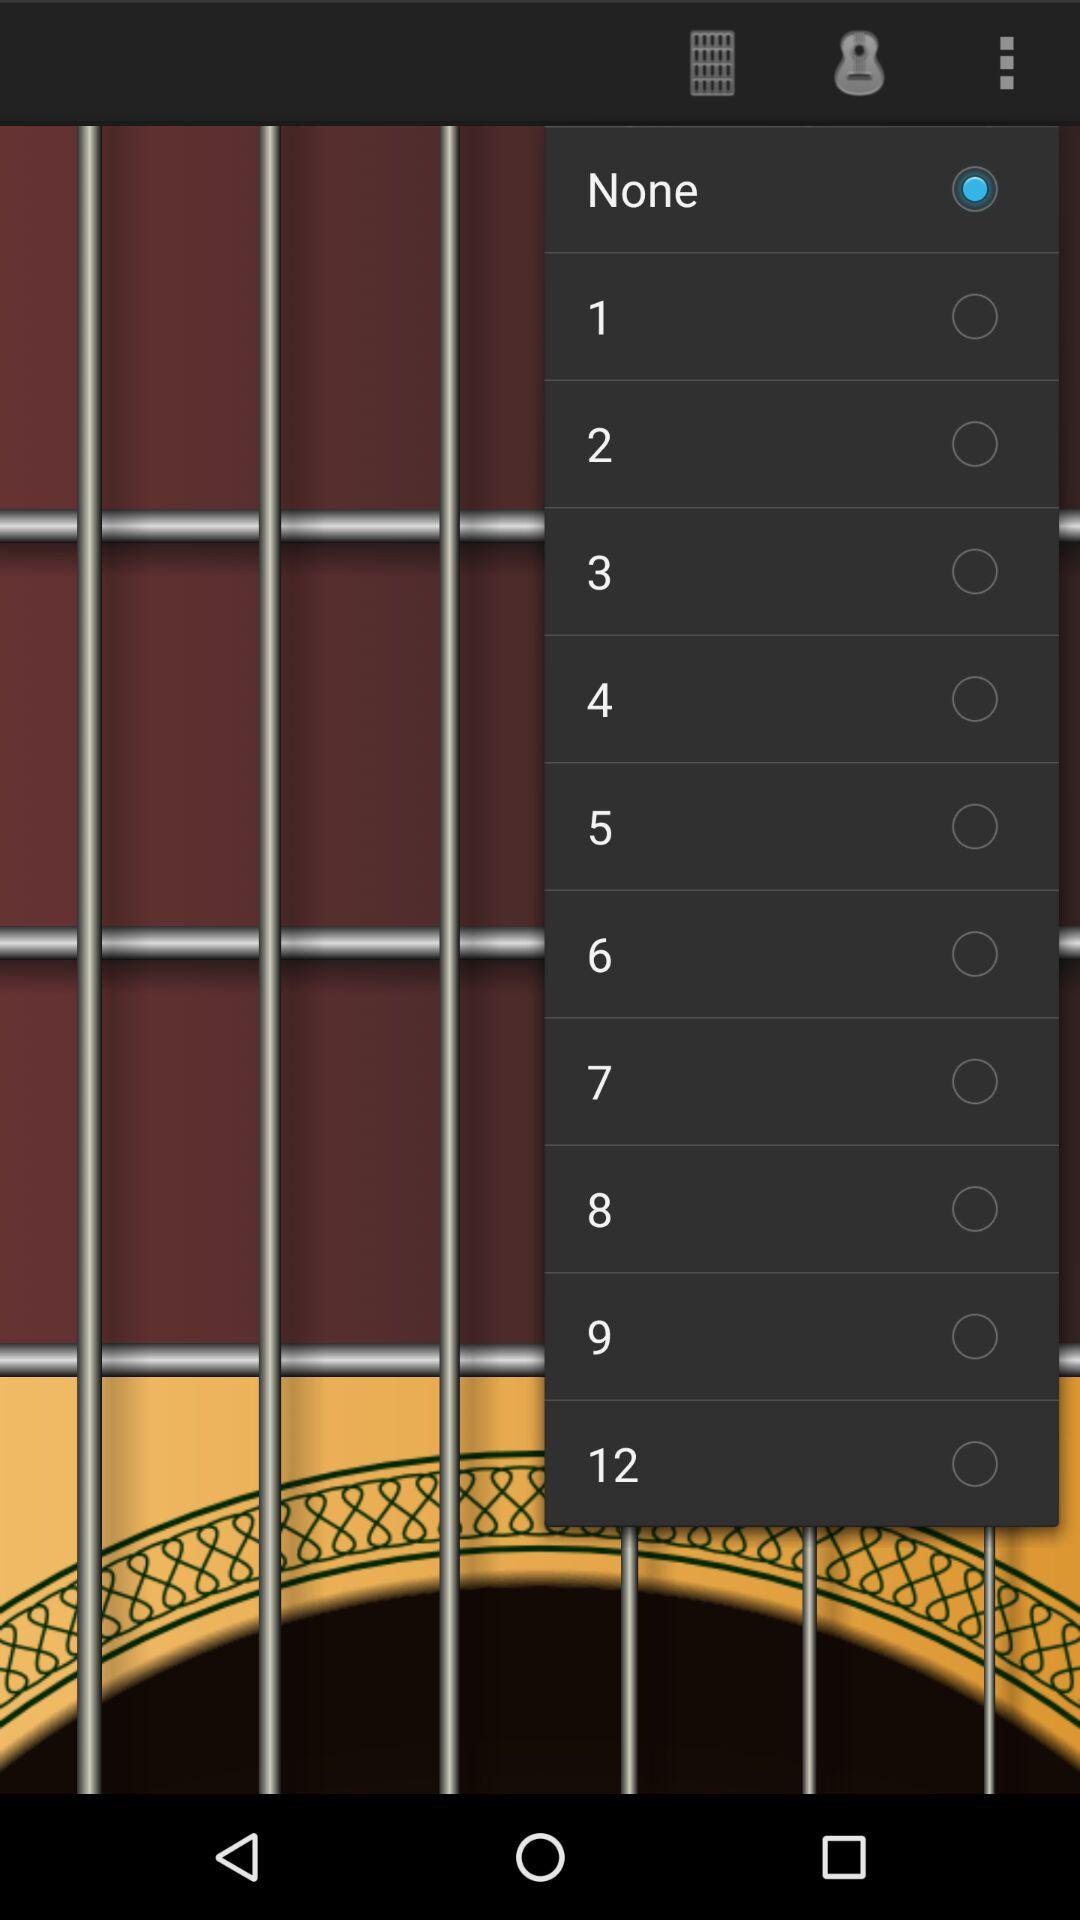Which option is selected? The selected option is "None". 